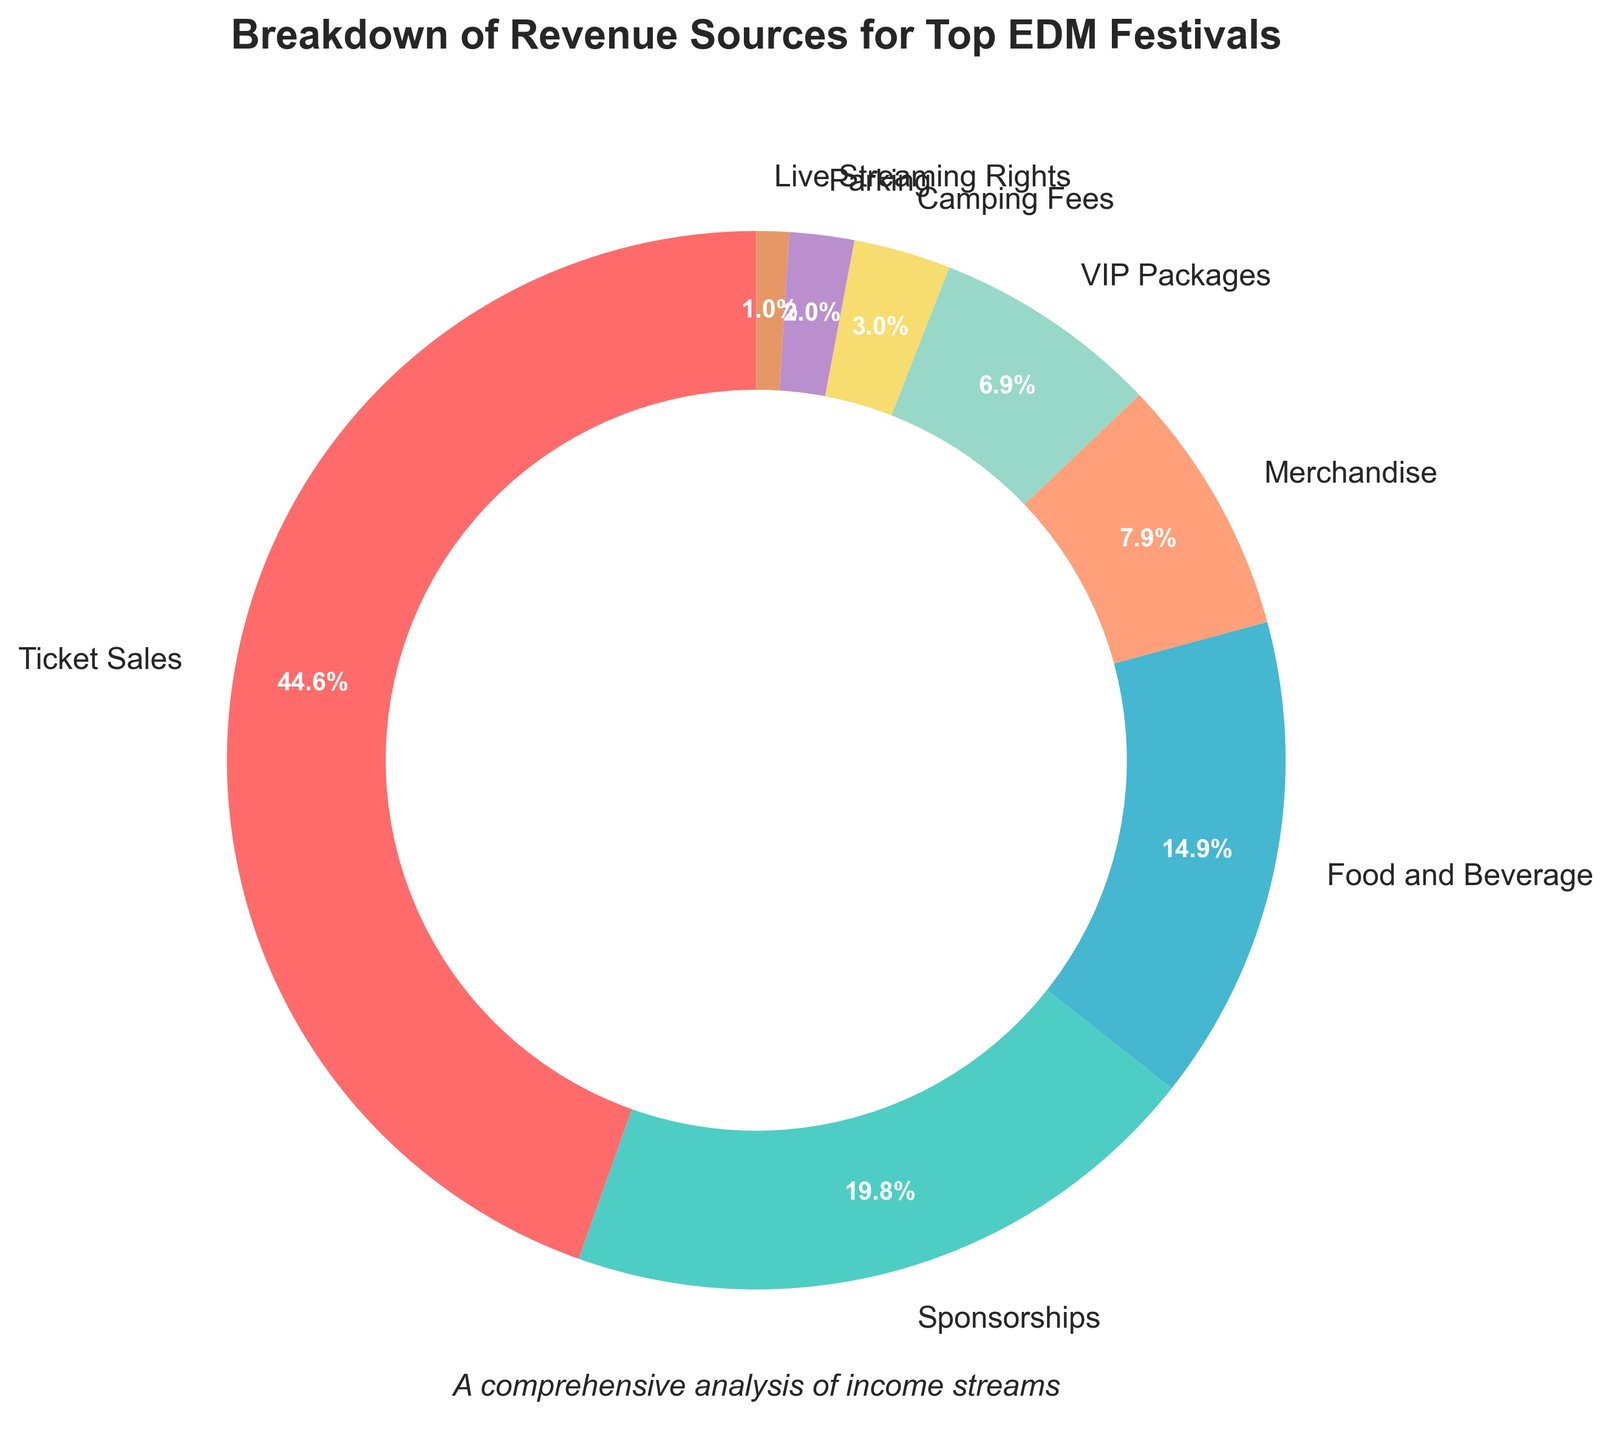What percentage of revenue comes from ticket sales compared to sponsorships? By looking at the pie chart, ticket sales account for 45% of the revenue while sponsorships make up 20%. To compare them, we see that ticket sales contribute more than sponsorships.
Answer: 45% vs 20% What is the combined percentage of revenue from merchandise and VIP packages? According to the pie chart, merchandise contributes 8% and VIP packages contribute 7%. Adding these together gives 8% + 7% = 15%.
Answer: 15% Which revenue source contributes the least to the overall revenue? The smallest segment in the pie chart, both in size and listed percentage, is Live Streaming Rights, which contributes 1% to the overall revenue.
Answer: Live Streaming Rights (1%) Is the revenue from food and beverage greater than the revenue from parking and camping fees combined? The pie chart indicates food and beverage account for 15% of revenue, while parking (2%) and camping fees (3%) combine for 5%. Since 15% > 5%, revenue from food and beverage is greater.
Answer: Yes What are the top three revenue sources based on their contributions? Observing the pie chart, the largest slices are from Ticket Sales (45%), Sponsorships (20%), and Food and Beverage (15%). Thus, these are the top three revenue sources.
Answer: Ticket Sales, Sponsorships, Food and Beverage How much more revenue do ticket sales generate compared to merchandise? Ticket sales generate 45% of revenue, while merchandise generates 8%, so the difference is 45% - 8% = 37%.
Answer: 37% What is the difference in percentage between the revenue from VIP packages and camping fees? VIP packages account for 7% and camping fees for 3%. The difference is 7% - 3% = 4%.
Answer: 4% What percentage of revenue is made from non-ticket sources? All percentages except ticket sales are summed: 20% Sponsorships + 15% Food and Beverage + 8% Merchandise + 7% VIP Packages + 3% Camping Fees + 2% Parking + 1% Live Streaming Rights = 56%.
Answer: 56% Does parking contribute more or less than half the revenue generated by merchandise? Parking contributes 2% of the revenue, while merchandise contributes 8%. To find half of merchandise's contribution, 8% / 2 = 4%. Since 2% < 4%, parking contributes less than half.
Answer: Less Which color represents the largest revenue source in the doughnut chart? The largest segment in the pie chart represents Ticket Sales, which is shown in red.
Answer: Red 